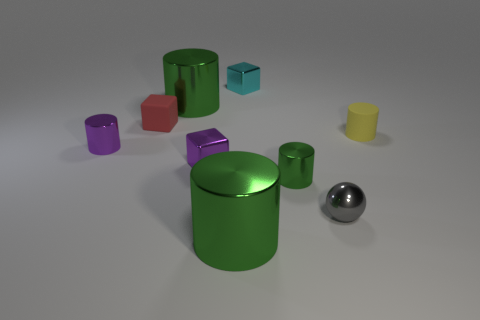The cyan object that is the same size as the gray metallic sphere is what shape?
Offer a very short reply. Cube. What number of things are either tiny metal objects or large purple balls?
Your response must be concise. 5. Are any tiny yellow cylinders visible?
Your response must be concise. Yes. Is the number of big shiny objects less than the number of big green rubber cylinders?
Your answer should be very brief. No. Is there a green shiny cylinder of the same size as the cyan cube?
Your answer should be compact. Yes. There is a small yellow object; is its shape the same as the matte object on the left side of the cyan block?
Give a very brief answer. No. How many blocks are gray objects or small cyan things?
Offer a very short reply. 1. What is the color of the tiny ball?
Offer a very short reply. Gray. Are there more gray balls than large shiny objects?
Your response must be concise. No. How many things are either small shiny cubes in front of the small red rubber block or purple cylinders?
Your response must be concise. 2. 